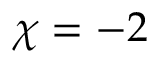<formula> <loc_0><loc_0><loc_500><loc_500>\chi = - 2</formula> 